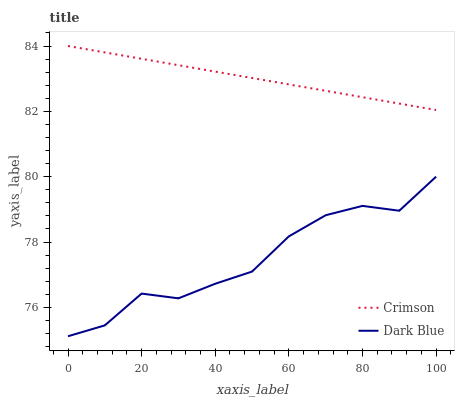Does Dark Blue have the minimum area under the curve?
Answer yes or no. Yes. Does Crimson have the maximum area under the curve?
Answer yes or no. Yes. Does Dark Blue have the maximum area under the curve?
Answer yes or no. No. Is Crimson the smoothest?
Answer yes or no. Yes. Is Dark Blue the roughest?
Answer yes or no. Yes. Is Dark Blue the smoothest?
Answer yes or no. No. Does Dark Blue have the lowest value?
Answer yes or no. Yes. Does Crimson have the highest value?
Answer yes or no. Yes. Does Dark Blue have the highest value?
Answer yes or no. No. Is Dark Blue less than Crimson?
Answer yes or no. Yes. Is Crimson greater than Dark Blue?
Answer yes or no. Yes. Does Dark Blue intersect Crimson?
Answer yes or no. No. 